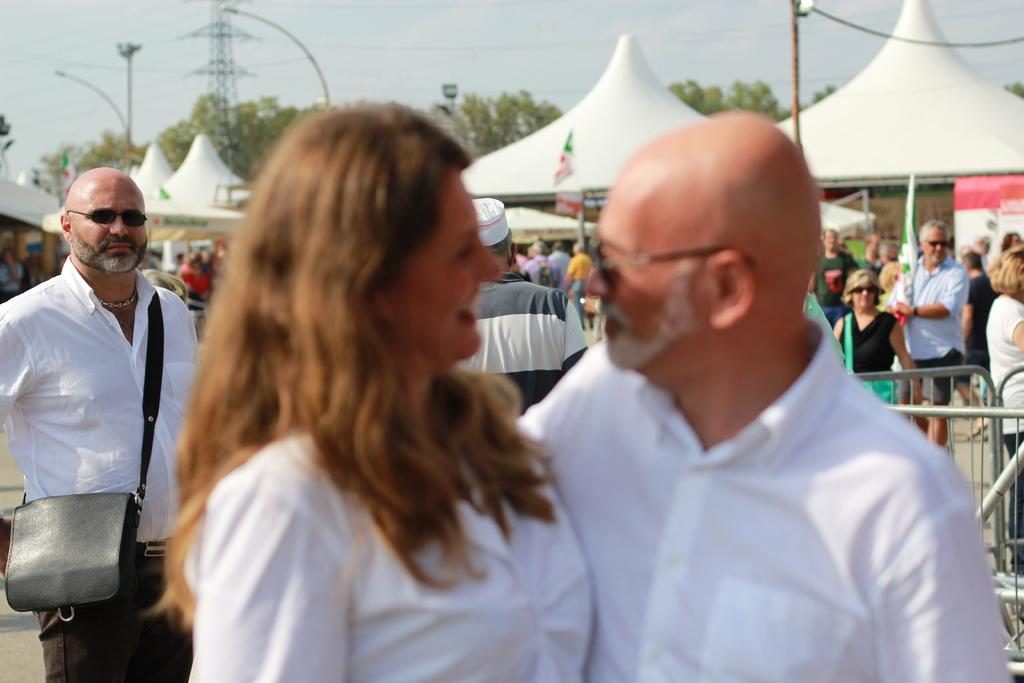How many people are in the center of the image? There are two people standing in the center of the image. What color are the dresses of the people in the center? Both people are wearing white color dresses. What can be seen in the background of the image? There are many people and trees visible in the background of the image. What type of star is visible in the image? There are no stars visible in the image. 